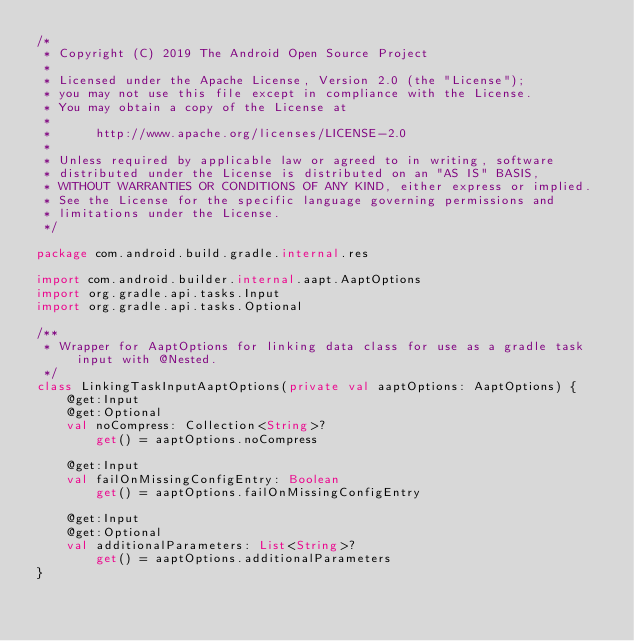Convert code to text. <code><loc_0><loc_0><loc_500><loc_500><_Kotlin_>/*
 * Copyright (C) 2019 The Android Open Source Project
 *
 * Licensed under the Apache License, Version 2.0 (the "License");
 * you may not use this file except in compliance with the License.
 * You may obtain a copy of the License at
 *
 *      http://www.apache.org/licenses/LICENSE-2.0
 *
 * Unless required by applicable law or agreed to in writing, software
 * distributed under the License is distributed on an "AS IS" BASIS,
 * WITHOUT WARRANTIES OR CONDITIONS OF ANY KIND, either express or implied.
 * See the License for the specific language governing permissions and
 * limitations under the License.
 */

package com.android.build.gradle.internal.res

import com.android.builder.internal.aapt.AaptOptions
import org.gradle.api.tasks.Input
import org.gradle.api.tasks.Optional

/**
 * Wrapper for AaptOptions for linking data class for use as a gradle task input with @Nested.
 */
class LinkingTaskInputAaptOptions(private val aaptOptions: AaptOptions) {
    @get:Input
    @get:Optional
    val noCompress: Collection<String>?
        get() = aaptOptions.noCompress

    @get:Input
    val failOnMissingConfigEntry: Boolean
        get() = aaptOptions.failOnMissingConfigEntry

    @get:Input
    @get:Optional
    val additionalParameters: List<String>?
        get() = aaptOptions.additionalParameters
}</code> 